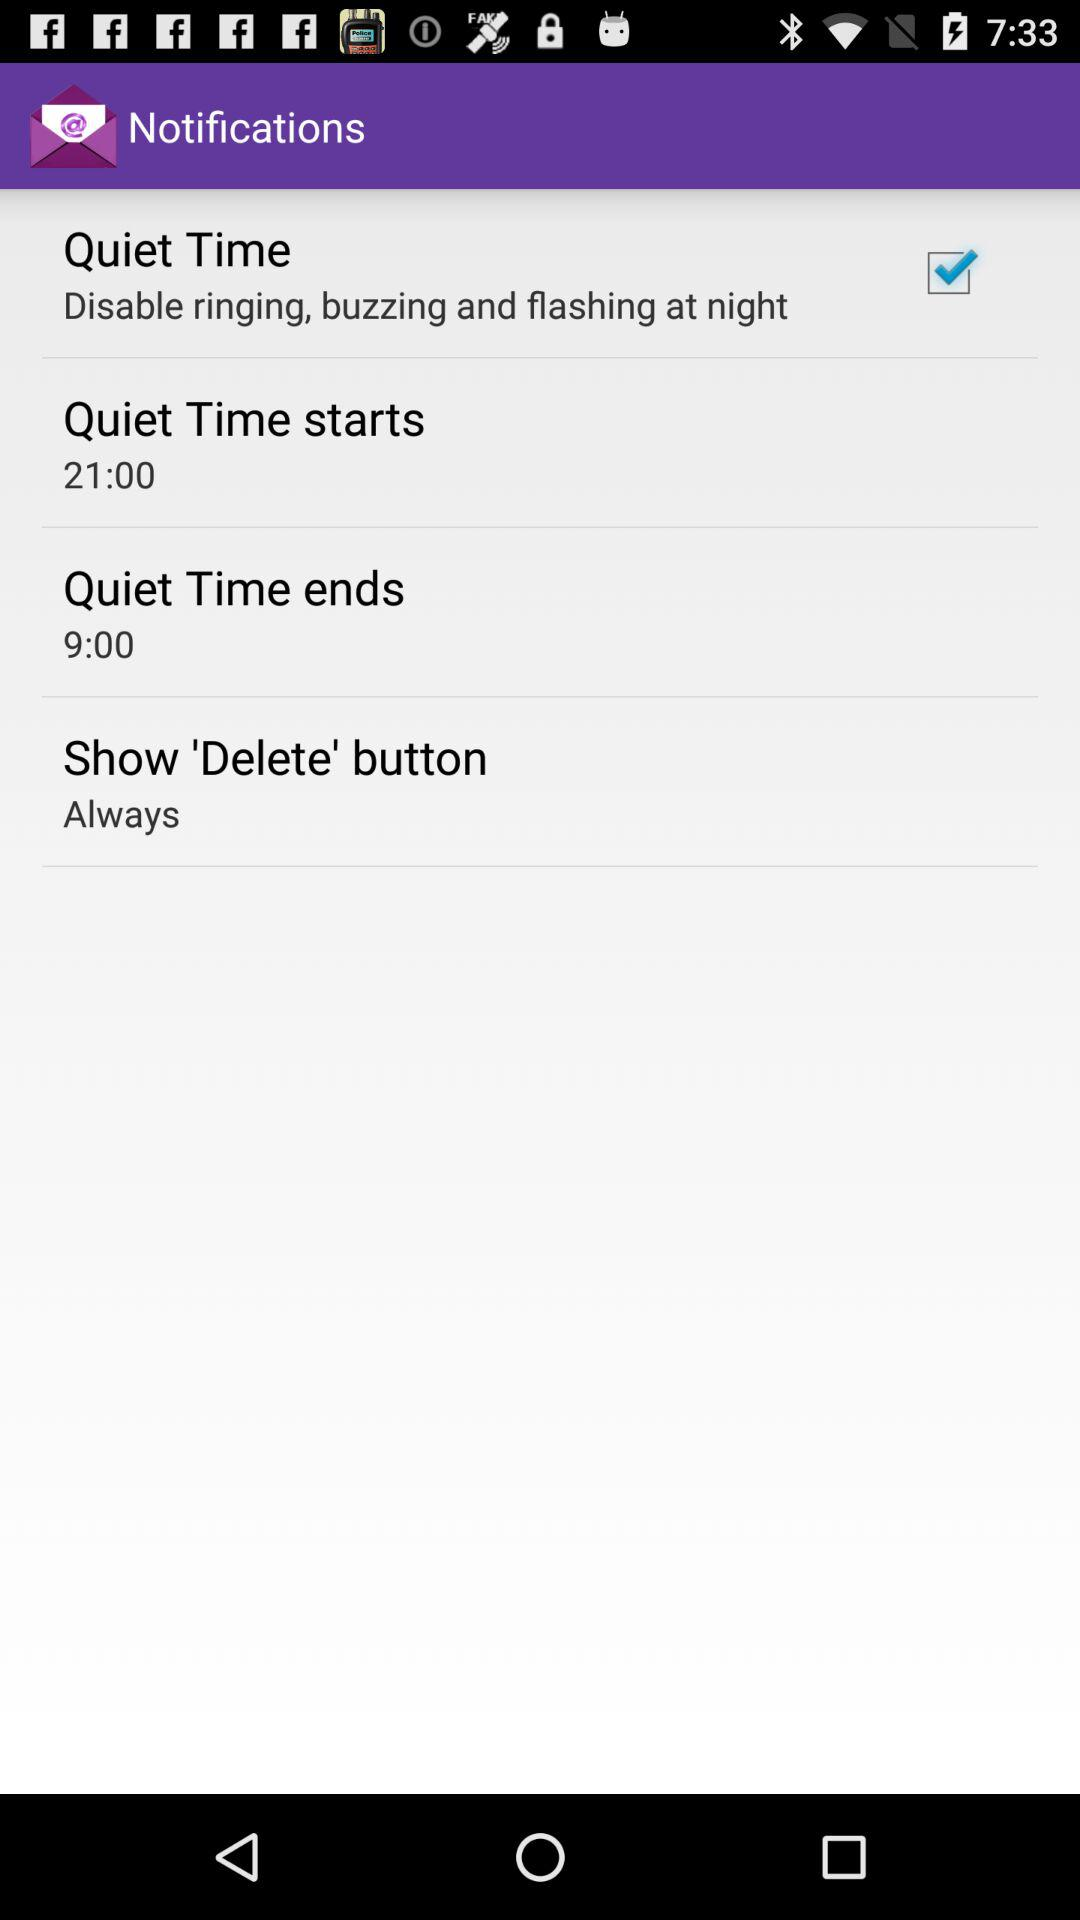What is the name of the application?
When the provided information is insufficient, respond with <no answer>. <no answer> 